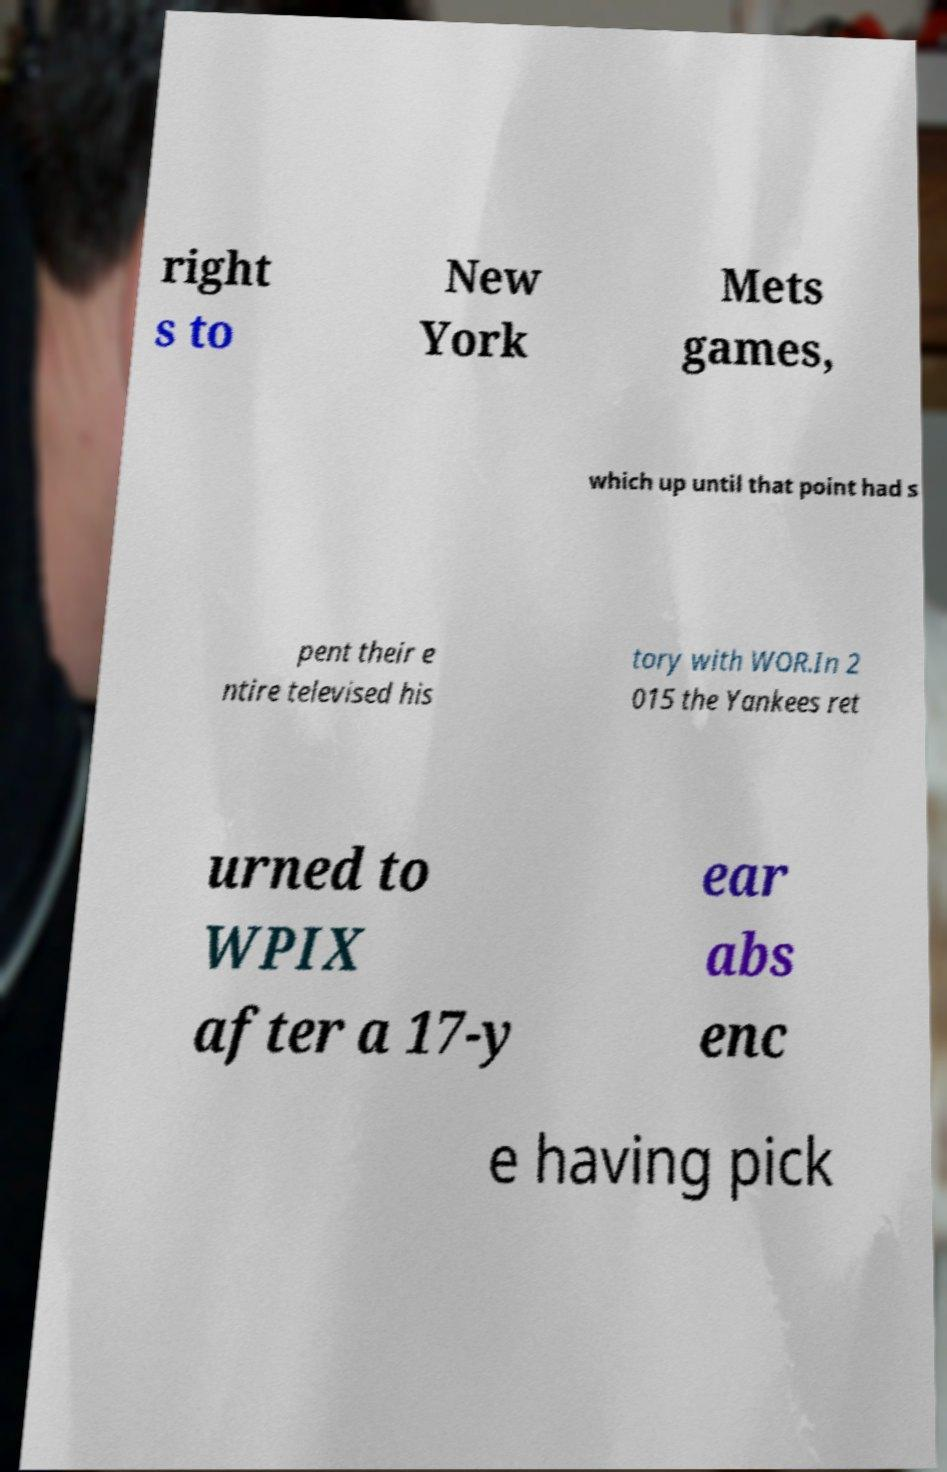There's text embedded in this image that I need extracted. Can you transcribe it verbatim? right s to New York Mets games, which up until that point had s pent their e ntire televised his tory with WOR.In 2 015 the Yankees ret urned to WPIX after a 17-y ear abs enc e having pick 